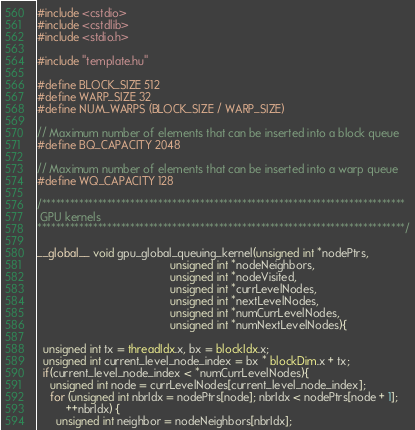Convert code to text. <code><loc_0><loc_0><loc_500><loc_500><_Cuda_>#include <cstdio>
#include <cstdlib>
#include <stdio.h>

#include "template.hu"

#define BLOCK_SIZE 512
#define WARP_SIZE 32
#define NUM_WARPS (BLOCK_SIZE / WARP_SIZE)

// Maximum number of elements that can be inserted into a block queue
#define BQ_CAPACITY 2048

// Maximum number of elements that can be inserted into a warp queue
#define WQ_CAPACITY 128

/******************************************************************************
 GPU kernels 
*******************************************************************************/

__global__ void gpu_global_queuing_kernel(unsigned int *nodePtrs,
                                          unsigned int *nodeNeighbors,
                                          unsigned int *nodeVisited,
                                          unsigned int *currLevelNodes,
                                          unsigned int *nextLevelNodes,
                                          unsigned int *numCurrLevelNodes,
                                          unsigned int *numNextLevelNodes){
  
  unsigned int tx = threadIdx.x, bx = blockIdx.x; 
  unsigned int current_level_node_index = bx * blockDim.x + tx;
  if(current_level_node_index < *numCurrLevelNodes){
    unsigned int node = currLevelNodes[current_level_node_index];
    for (unsigned int nbrIdx = nodePtrs[node]; nbrIdx < nodePtrs[node + 1];
         ++nbrIdx) {
      unsigned int neighbor = nodeNeighbors[nbrIdx];</code> 